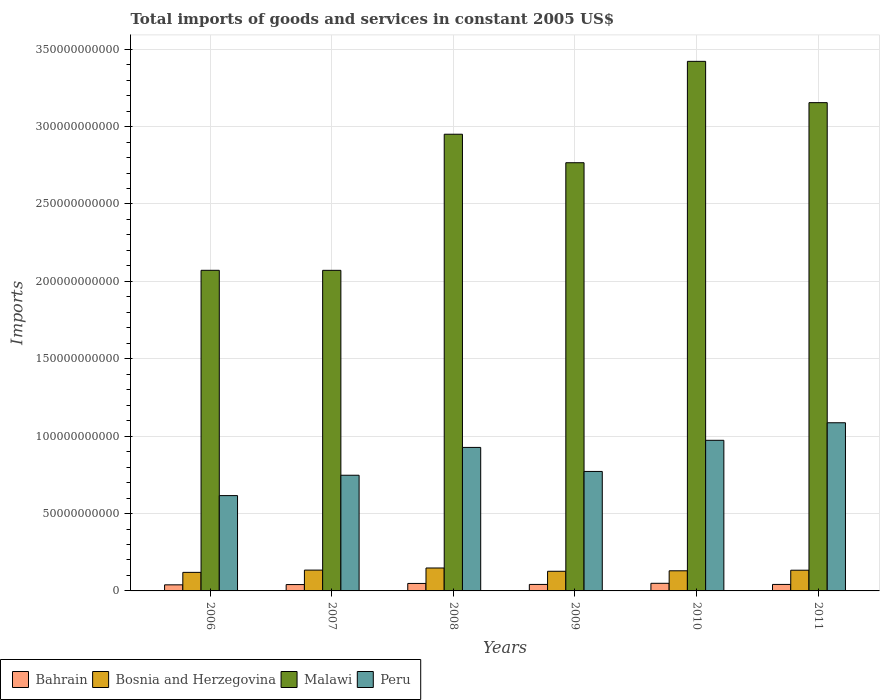How many different coloured bars are there?
Your answer should be very brief. 4. How many groups of bars are there?
Provide a succinct answer. 6. How many bars are there on the 2nd tick from the left?
Keep it short and to the point. 4. How many bars are there on the 2nd tick from the right?
Give a very brief answer. 4. What is the label of the 6th group of bars from the left?
Your answer should be very brief. 2011. In how many cases, is the number of bars for a given year not equal to the number of legend labels?
Offer a terse response. 0. What is the total imports of goods and services in Peru in 2011?
Ensure brevity in your answer.  1.09e+11. Across all years, what is the maximum total imports of goods and services in Peru?
Provide a succinct answer. 1.09e+11. Across all years, what is the minimum total imports of goods and services in Peru?
Make the answer very short. 6.16e+1. In which year was the total imports of goods and services in Bahrain maximum?
Offer a very short reply. 2010. What is the total total imports of goods and services in Malawi in the graph?
Give a very brief answer. 1.64e+12. What is the difference between the total imports of goods and services in Malawi in 2010 and that in 2011?
Provide a succinct answer. 2.67e+1. What is the difference between the total imports of goods and services in Peru in 2011 and the total imports of goods and services in Bahrain in 2006?
Your response must be concise. 1.05e+11. What is the average total imports of goods and services in Bahrain per year?
Ensure brevity in your answer.  4.36e+09. In the year 2007, what is the difference between the total imports of goods and services in Bosnia and Herzegovina and total imports of goods and services in Peru?
Provide a short and direct response. -6.13e+1. In how many years, is the total imports of goods and services in Bosnia and Herzegovina greater than 130000000000 US$?
Your answer should be very brief. 0. What is the ratio of the total imports of goods and services in Peru in 2007 to that in 2008?
Your response must be concise. 0.81. Is the total imports of goods and services in Peru in 2010 less than that in 2011?
Ensure brevity in your answer.  Yes. Is the difference between the total imports of goods and services in Bosnia and Herzegovina in 2010 and 2011 greater than the difference between the total imports of goods and services in Peru in 2010 and 2011?
Your response must be concise. Yes. What is the difference between the highest and the second highest total imports of goods and services in Peru?
Make the answer very short. 1.13e+1. What is the difference between the highest and the lowest total imports of goods and services in Bosnia and Herzegovina?
Keep it short and to the point. 2.83e+09. Is the sum of the total imports of goods and services in Bahrain in 2006 and 2008 greater than the maximum total imports of goods and services in Bosnia and Herzegovina across all years?
Your answer should be compact. No. Is it the case that in every year, the sum of the total imports of goods and services in Bahrain and total imports of goods and services in Bosnia and Herzegovina is greater than the sum of total imports of goods and services in Malawi and total imports of goods and services in Peru?
Keep it short and to the point. No. What does the 3rd bar from the right in 2006 represents?
Your answer should be very brief. Bosnia and Herzegovina. What is the difference between two consecutive major ticks on the Y-axis?
Offer a terse response. 5.00e+1. Does the graph contain grids?
Keep it short and to the point. Yes. Where does the legend appear in the graph?
Ensure brevity in your answer.  Bottom left. What is the title of the graph?
Ensure brevity in your answer.  Total imports of goods and services in constant 2005 US$. What is the label or title of the Y-axis?
Offer a terse response. Imports. What is the Imports of Bahrain in 2006?
Keep it short and to the point. 3.93e+09. What is the Imports of Bosnia and Herzegovina in 2006?
Offer a very short reply. 1.20e+1. What is the Imports in Malawi in 2006?
Give a very brief answer. 2.07e+11. What is the Imports of Peru in 2006?
Your response must be concise. 6.16e+1. What is the Imports of Bahrain in 2007?
Provide a succinct answer. 4.10e+09. What is the Imports in Bosnia and Herzegovina in 2007?
Your answer should be very brief. 1.35e+1. What is the Imports of Malawi in 2007?
Your answer should be very brief. 2.07e+11. What is the Imports of Peru in 2007?
Your answer should be compact. 7.47e+1. What is the Imports of Bahrain in 2008?
Provide a succinct answer. 4.83e+09. What is the Imports of Bosnia and Herzegovina in 2008?
Your answer should be compact. 1.48e+1. What is the Imports of Malawi in 2008?
Give a very brief answer. 2.95e+11. What is the Imports of Peru in 2008?
Make the answer very short. 9.27e+1. What is the Imports of Bahrain in 2009?
Keep it short and to the point. 4.20e+09. What is the Imports in Bosnia and Herzegovina in 2009?
Give a very brief answer. 1.27e+1. What is the Imports in Malawi in 2009?
Provide a short and direct response. 2.77e+11. What is the Imports of Peru in 2009?
Offer a terse response. 7.72e+1. What is the Imports of Bahrain in 2010?
Provide a short and direct response. 4.92e+09. What is the Imports in Bosnia and Herzegovina in 2010?
Keep it short and to the point. 1.30e+1. What is the Imports of Malawi in 2010?
Make the answer very short. 3.42e+11. What is the Imports in Peru in 2010?
Ensure brevity in your answer.  9.73e+1. What is the Imports in Bahrain in 2011?
Provide a short and direct response. 4.20e+09. What is the Imports in Bosnia and Herzegovina in 2011?
Your answer should be very brief. 1.34e+1. What is the Imports in Malawi in 2011?
Make the answer very short. 3.15e+11. What is the Imports in Peru in 2011?
Make the answer very short. 1.09e+11. Across all years, what is the maximum Imports of Bahrain?
Offer a very short reply. 4.92e+09. Across all years, what is the maximum Imports of Bosnia and Herzegovina?
Give a very brief answer. 1.48e+1. Across all years, what is the maximum Imports of Malawi?
Your answer should be very brief. 3.42e+11. Across all years, what is the maximum Imports of Peru?
Provide a succinct answer. 1.09e+11. Across all years, what is the minimum Imports of Bahrain?
Provide a succinct answer. 3.93e+09. Across all years, what is the minimum Imports in Bosnia and Herzegovina?
Provide a succinct answer. 1.20e+1. Across all years, what is the minimum Imports in Malawi?
Offer a terse response. 2.07e+11. Across all years, what is the minimum Imports of Peru?
Offer a terse response. 6.16e+1. What is the total Imports in Bahrain in the graph?
Make the answer very short. 2.62e+1. What is the total Imports in Bosnia and Herzegovina in the graph?
Provide a short and direct response. 7.93e+1. What is the total Imports in Malawi in the graph?
Your answer should be very brief. 1.64e+12. What is the total Imports in Peru in the graph?
Provide a succinct answer. 5.12e+11. What is the difference between the Imports in Bahrain in 2006 and that in 2007?
Offer a very short reply. -1.75e+08. What is the difference between the Imports in Bosnia and Herzegovina in 2006 and that in 2007?
Your response must be concise. -1.47e+09. What is the difference between the Imports in Malawi in 2006 and that in 2007?
Your answer should be very brief. 2.19e+07. What is the difference between the Imports in Peru in 2006 and that in 2007?
Ensure brevity in your answer.  -1.31e+1. What is the difference between the Imports in Bahrain in 2006 and that in 2008?
Your answer should be very brief. -9.05e+08. What is the difference between the Imports of Bosnia and Herzegovina in 2006 and that in 2008?
Provide a succinct answer. -2.83e+09. What is the difference between the Imports of Malawi in 2006 and that in 2008?
Offer a very short reply. -8.79e+1. What is the difference between the Imports in Peru in 2006 and that in 2008?
Provide a short and direct response. -3.11e+1. What is the difference between the Imports of Bahrain in 2006 and that in 2009?
Make the answer very short. -2.68e+08. What is the difference between the Imports in Bosnia and Herzegovina in 2006 and that in 2009?
Keep it short and to the point. -7.04e+08. What is the difference between the Imports in Malawi in 2006 and that in 2009?
Offer a very short reply. -6.95e+1. What is the difference between the Imports of Peru in 2006 and that in 2009?
Give a very brief answer. -1.56e+1. What is the difference between the Imports in Bahrain in 2006 and that in 2010?
Offer a terse response. -9.95e+08. What is the difference between the Imports of Bosnia and Herzegovina in 2006 and that in 2010?
Provide a succinct answer. -1.02e+09. What is the difference between the Imports in Malawi in 2006 and that in 2010?
Your answer should be very brief. -1.35e+11. What is the difference between the Imports in Peru in 2006 and that in 2010?
Provide a short and direct response. -3.57e+1. What is the difference between the Imports in Bahrain in 2006 and that in 2011?
Offer a terse response. -2.68e+08. What is the difference between the Imports in Bosnia and Herzegovina in 2006 and that in 2011?
Ensure brevity in your answer.  -1.40e+09. What is the difference between the Imports of Malawi in 2006 and that in 2011?
Offer a very short reply. -1.08e+11. What is the difference between the Imports in Peru in 2006 and that in 2011?
Keep it short and to the point. -4.71e+1. What is the difference between the Imports of Bahrain in 2007 and that in 2008?
Make the answer very short. -7.30e+08. What is the difference between the Imports of Bosnia and Herzegovina in 2007 and that in 2008?
Offer a very short reply. -1.36e+09. What is the difference between the Imports of Malawi in 2007 and that in 2008?
Offer a very short reply. -8.79e+1. What is the difference between the Imports of Peru in 2007 and that in 2008?
Offer a very short reply. -1.80e+1. What is the difference between the Imports of Bahrain in 2007 and that in 2009?
Your answer should be very brief. -9.39e+07. What is the difference between the Imports of Bosnia and Herzegovina in 2007 and that in 2009?
Ensure brevity in your answer.  7.62e+08. What is the difference between the Imports in Malawi in 2007 and that in 2009?
Give a very brief answer. -6.95e+1. What is the difference between the Imports in Peru in 2007 and that in 2009?
Your answer should be compact. -2.46e+09. What is the difference between the Imports of Bahrain in 2007 and that in 2010?
Your response must be concise. -8.20e+08. What is the difference between the Imports in Bosnia and Herzegovina in 2007 and that in 2010?
Ensure brevity in your answer.  4.48e+08. What is the difference between the Imports of Malawi in 2007 and that in 2010?
Keep it short and to the point. -1.35e+11. What is the difference between the Imports in Peru in 2007 and that in 2010?
Keep it short and to the point. -2.26e+1. What is the difference between the Imports of Bahrain in 2007 and that in 2011?
Offer a very short reply. -9.29e+07. What is the difference between the Imports of Bosnia and Herzegovina in 2007 and that in 2011?
Keep it short and to the point. 6.82e+07. What is the difference between the Imports of Malawi in 2007 and that in 2011?
Give a very brief answer. -1.08e+11. What is the difference between the Imports in Peru in 2007 and that in 2011?
Your answer should be very brief. -3.39e+1. What is the difference between the Imports of Bahrain in 2008 and that in 2009?
Your answer should be compact. 6.36e+08. What is the difference between the Imports of Bosnia and Herzegovina in 2008 and that in 2009?
Ensure brevity in your answer.  2.13e+09. What is the difference between the Imports of Malawi in 2008 and that in 2009?
Give a very brief answer. 1.84e+1. What is the difference between the Imports of Peru in 2008 and that in 2009?
Your answer should be very brief. 1.55e+1. What is the difference between the Imports of Bahrain in 2008 and that in 2010?
Your answer should be very brief. -9.00e+07. What is the difference between the Imports of Bosnia and Herzegovina in 2008 and that in 2010?
Make the answer very short. 1.81e+09. What is the difference between the Imports in Malawi in 2008 and that in 2010?
Provide a short and direct response. -4.71e+1. What is the difference between the Imports of Peru in 2008 and that in 2010?
Offer a terse response. -4.60e+09. What is the difference between the Imports in Bahrain in 2008 and that in 2011?
Provide a succinct answer. 6.38e+08. What is the difference between the Imports of Bosnia and Herzegovina in 2008 and that in 2011?
Make the answer very short. 1.43e+09. What is the difference between the Imports in Malawi in 2008 and that in 2011?
Provide a short and direct response. -2.04e+1. What is the difference between the Imports of Peru in 2008 and that in 2011?
Your answer should be very brief. -1.59e+1. What is the difference between the Imports in Bahrain in 2009 and that in 2010?
Your answer should be compact. -7.26e+08. What is the difference between the Imports in Bosnia and Herzegovina in 2009 and that in 2010?
Ensure brevity in your answer.  -3.15e+08. What is the difference between the Imports in Malawi in 2009 and that in 2010?
Offer a very short reply. -6.55e+1. What is the difference between the Imports of Peru in 2009 and that in 2010?
Give a very brief answer. -2.01e+1. What is the difference between the Imports of Bahrain in 2009 and that in 2011?
Offer a very short reply. 1.00e+06. What is the difference between the Imports in Bosnia and Herzegovina in 2009 and that in 2011?
Your answer should be compact. -6.94e+08. What is the difference between the Imports in Malawi in 2009 and that in 2011?
Offer a very short reply. -3.88e+1. What is the difference between the Imports in Peru in 2009 and that in 2011?
Your response must be concise. -3.15e+1. What is the difference between the Imports in Bahrain in 2010 and that in 2011?
Provide a succinct answer. 7.28e+08. What is the difference between the Imports in Bosnia and Herzegovina in 2010 and that in 2011?
Offer a terse response. -3.79e+08. What is the difference between the Imports of Malawi in 2010 and that in 2011?
Make the answer very short. 2.67e+1. What is the difference between the Imports in Peru in 2010 and that in 2011?
Keep it short and to the point. -1.13e+1. What is the difference between the Imports in Bahrain in 2006 and the Imports in Bosnia and Herzegovina in 2007?
Keep it short and to the point. -9.52e+09. What is the difference between the Imports in Bahrain in 2006 and the Imports in Malawi in 2007?
Ensure brevity in your answer.  -2.03e+11. What is the difference between the Imports in Bahrain in 2006 and the Imports in Peru in 2007?
Your response must be concise. -7.08e+1. What is the difference between the Imports in Bosnia and Herzegovina in 2006 and the Imports in Malawi in 2007?
Provide a short and direct response. -1.95e+11. What is the difference between the Imports of Bosnia and Herzegovina in 2006 and the Imports of Peru in 2007?
Provide a short and direct response. -6.27e+1. What is the difference between the Imports of Malawi in 2006 and the Imports of Peru in 2007?
Your answer should be compact. 1.32e+11. What is the difference between the Imports of Bahrain in 2006 and the Imports of Bosnia and Herzegovina in 2008?
Give a very brief answer. -1.09e+1. What is the difference between the Imports of Bahrain in 2006 and the Imports of Malawi in 2008?
Your response must be concise. -2.91e+11. What is the difference between the Imports of Bahrain in 2006 and the Imports of Peru in 2008?
Provide a succinct answer. -8.88e+1. What is the difference between the Imports in Bosnia and Herzegovina in 2006 and the Imports in Malawi in 2008?
Make the answer very short. -2.83e+11. What is the difference between the Imports of Bosnia and Herzegovina in 2006 and the Imports of Peru in 2008?
Give a very brief answer. -8.07e+1. What is the difference between the Imports of Malawi in 2006 and the Imports of Peru in 2008?
Keep it short and to the point. 1.14e+11. What is the difference between the Imports in Bahrain in 2006 and the Imports in Bosnia and Herzegovina in 2009?
Make the answer very short. -8.76e+09. What is the difference between the Imports in Bahrain in 2006 and the Imports in Malawi in 2009?
Offer a very short reply. -2.73e+11. What is the difference between the Imports of Bahrain in 2006 and the Imports of Peru in 2009?
Your answer should be very brief. -7.33e+1. What is the difference between the Imports in Bosnia and Herzegovina in 2006 and the Imports in Malawi in 2009?
Provide a succinct answer. -2.65e+11. What is the difference between the Imports in Bosnia and Herzegovina in 2006 and the Imports in Peru in 2009?
Your answer should be compact. -6.52e+1. What is the difference between the Imports of Malawi in 2006 and the Imports of Peru in 2009?
Your response must be concise. 1.30e+11. What is the difference between the Imports of Bahrain in 2006 and the Imports of Bosnia and Herzegovina in 2010?
Keep it short and to the point. -9.08e+09. What is the difference between the Imports in Bahrain in 2006 and the Imports in Malawi in 2010?
Give a very brief answer. -3.38e+11. What is the difference between the Imports in Bahrain in 2006 and the Imports in Peru in 2010?
Provide a succinct answer. -9.34e+1. What is the difference between the Imports of Bosnia and Herzegovina in 2006 and the Imports of Malawi in 2010?
Provide a short and direct response. -3.30e+11. What is the difference between the Imports of Bosnia and Herzegovina in 2006 and the Imports of Peru in 2010?
Give a very brief answer. -8.53e+1. What is the difference between the Imports in Malawi in 2006 and the Imports in Peru in 2010?
Offer a very short reply. 1.10e+11. What is the difference between the Imports of Bahrain in 2006 and the Imports of Bosnia and Herzegovina in 2011?
Your answer should be compact. -9.46e+09. What is the difference between the Imports in Bahrain in 2006 and the Imports in Malawi in 2011?
Offer a terse response. -3.12e+11. What is the difference between the Imports in Bahrain in 2006 and the Imports in Peru in 2011?
Your answer should be compact. -1.05e+11. What is the difference between the Imports in Bosnia and Herzegovina in 2006 and the Imports in Malawi in 2011?
Your answer should be very brief. -3.03e+11. What is the difference between the Imports in Bosnia and Herzegovina in 2006 and the Imports in Peru in 2011?
Your answer should be very brief. -9.67e+1. What is the difference between the Imports of Malawi in 2006 and the Imports of Peru in 2011?
Make the answer very short. 9.85e+1. What is the difference between the Imports in Bahrain in 2007 and the Imports in Bosnia and Herzegovina in 2008?
Make the answer very short. -1.07e+1. What is the difference between the Imports in Bahrain in 2007 and the Imports in Malawi in 2008?
Your answer should be compact. -2.91e+11. What is the difference between the Imports of Bahrain in 2007 and the Imports of Peru in 2008?
Provide a short and direct response. -8.86e+1. What is the difference between the Imports of Bosnia and Herzegovina in 2007 and the Imports of Malawi in 2008?
Your answer should be very brief. -2.82e+11. What is the difference between the Imports of Bosnia and Herzegovina in 2007 and the Imports of Peru in 2008?
Make the answer very short. -7.93e+1. What is the difference between the Imports of Malawi in 2007 and the Imports of Peru in 2008?
Your response must be concise. 1.14e+11. What is the difference between the Imports of Bahrain in 2007 and the Imports of Bosnia and Herzegovina in 2009?
Offer a very short reply. -8.59e+09. What is the difference between the Imports in Bahrain in 2007 and the Imports in Malawi in 2009?
Offer a terse response. -2.73e+11. What is the difference between the Imports of Bahrain in 2007 and the Imports of Peru in 2009?
Give a very brief answer. -7.31e+1. What is the difference between the Imports in Bosnia and Herzegovina in 2007 and the Imports in Malawi in 2009?
Provide a succinct answer. -2.63e+11. What is the difference between the Imports of Bosnia and Herzegovina in 2007 and the Imports of Peru in 2009?
Your answer should be very brief. -6.37e+1. What is the difference between the Imports in Malawi in 2007 and the Imports in Peru in 2009?
Keep it short and to the point. 1.30e+11. What is the difference between the Imports of Bahrain in 2007 and the Imports of Bosnia and Herzegovina in 2010?
Ensure brevity in your answer.  -8.90e+09. What is the difference between the Imports in Bahrain in 2007 and the Imports in Malawi in 2010?
Offer a very short reply. -3.38e+11. What is the difference between the Imports of Bahrain in 2007 and the Imports of Peru in 2010?
Make the answer very short. -9.32e+1. What is the difference between the Imports in Bosnia and Herzegovina in 2007 and the Imports in Malawi in 2010?
Give a very brief answer. -3.29e+11. What is the difference between the Imports of Bosnia and Herzegovina in 2007 and the Imports of Peru in 2010?
Your answer should be compact. -8.39e+1. What is the difference between the Imports of Malawi in 2007 and the Imports of Peru in 2010?
Give a very brief answer. 1.10e+11. What is the difference between the Imports of Bahrain in 2007 and the Imports of Bosnia and Herzegovina in 2011?
Your response must be concise. -9.28e+09. What is the difference between the Imports of Bahrain in 2007 and the Imports of Malawi in 2011?
Your answer should be very brief. -3.11e+11. What is the difference between the Imports in Bahrain in 2007 and the Imports in Peru in 2011?
Your answer should be compact. -1.05e+11. What is the difference between the Imports in Bosnia and Herzegovina in 2007 and the Imports in Malawi in 2011?
Your answer should be very brief. -3.02e+11. What is the difference between the Imports in Bosnia and Herzegovina in 2007 and the Imports in Peru in 2011?
Your response must be concise. -9.52e+1. What is the difference between the Imports in Malawi in 2007 and the Imports in Peru in 2011?
Provide a short and direct response. 9.85e+1. What is the difference between the Imports in Bahrain in 2008 and the Imports in Bosnia and Herzegovina in 2009?
Provide a short and direct response. -7.86e+09. What is the difference between the Imports in Bahrain in 2008 and the Imports in Malawi in 2009?
Make the answer very short. -2.72e+11. What is the difference between the Imports in Bahrain in 2008 and the Imports in Peru in 2009?
Offer a very short reply. -7.24e+1. What is the difference between the Imports of Bosnia and Herzegovina in 2008 and the Imports of Malawi in 2009?
Give a very brief answer. -2.62e+11. What is the difference between the Imports of Bosnia and Herzegovina in 2008 and the Imports of Peru in 2009?
Ensure brevity in your answer.  -6.24e+1. What is the difference between the Imports in Malawi in 2008 and the Imports in Peru in 2009?
Make the answer very short. 2.18e+11. What is the difference between the Imports in Bahrain in 2008 and the Imports in Bosnia and Herzegovina in 2010?
Your answer should be very brief. -8.17e+09. What is the difference between the Imports in Bahrain in 2008 and the Imports in Malawi in 2010?
Offer a terse response. -3.37e+11. What is the difference between the Imports of Bahrain in 2008 and the Imports of Peru in 2010?
Keep it short and to the point. -9.25e+1. What is the difference between the Imports in Bosnia and Herzegovina in 2008 and the Imports in Malawi in 2010?
Offer a very short reply. -3.27e+11. What is the difference between the Imports of Bosnia and Herzegovina in 2008 and the Imports of Peru in 2010?
Your answer should be very brief. -8.25e+1. What is the difference between the Imports of Malawi in 2008 and the Imports of Peru in 2010?
Offer a terse response. 1.98e+11. What is the difference between the Imports of Bahrain in 2008 and the Imports of Bosnia and Herzegovina in 2011?
Offer a very short reply. -8.55e+09. What is the difference between the Imports of Bahrain in 2008 and the Imports of Malawi in 2011?
Your answer should be compact. -3.11e+11. What is the difference between the Imports of Bahrain in 2008 and the Imports of Peru in 2011?
Make the answer very short. -1.04e+11. What is the difference between the Imports in Bosnia and Herzegovina in 2008 and the Imports in Malawi in 2011?
Your response must be concise. -3.01e+11. What is the difference between the Imports in Bosnia and Herzegovina in 2008 and the Imports in Peru in 2011?
Keep it short and to the point. -9.38e+1. What is the difference between the Imports of Malawi in 2008 and the Imports of Peru in 2011?
Provide a short and direct response. 1.86e+11. What is the difference between the Imports in Bahrain in 2009 and the Imports in Bosnia and Herzegovina in 2010?
Make the answer very short. -8.81e+09. What is the difference between the Imports of Bahrain in 2009 and the Imports of Malawi in 2010?
Your answer should be compact. -3.38e+11. What is the difference between the Imports of Bahrain in 2009 and the Imports of Peru in 2010?
Provide a short and direct response. -9.31e+1. What is the difference between the Imports of Bosnia and Herzegovina in 2009 and the Imports of Malawi in 2010?
Provide a short and direct response. -3.29e+11. What is the difference between the Imports in Bosnia and Herzegovina in 2009 and the Imports in Peru in 2010?
Provide a short and direct response. -8.46e+1. What is the difference between the Imports in Malawi in 2009 and the Imports in Peru in 2010?
Your answer should be very brief. 1.79e+11. What is the difference between the Imports of Bahrain in 2009 and the Imports of Bosnia and Herzegovina in 2011?
Your response must be concise. -9.19e+09. What is the difference between the Imports in Bahrain in 2009 and the Imports in Malawi in 2011?
Your response must be concise. -3.11e+11. What is the difference between the Imports in Bahrain in 2009 and the Imports in Peru in 2011?
Provide a short and direct response. -1.04e+11. What is the difference between the Imports of Bosnia and Herzegovina in 2009 and the Imports of Malawi in 2011?
Your answer should be compact. -3.03e+11. What is the difference between the Imports of Bosnia and Herzegovina in 2009 and the Imports of Peru in 2011?
Make the answer very short. -9.60e+1. What is the difference between the Imports of Malawi in 2009 and the Imports of Peru in 2011?
Give a very brief answer. 1.68e+11. What is the difference between the Imports in Bahrain in 2010 and the Imports in Bosnia and Herzegovina in 2011?
Provide a succinct answer. -8.46e+09. What is the difference between the Imports in Bahrain in 2010 and the Imports in Malawi in 2011?
Offer a terse response. -3.11e+11. What is the difference between the Imports in Bahrain in 2010 and the Imports in Peru in 2011?
Offer a terse response. -1.04e+11. What is the difference between the Imports in Bosnia and Herzegovina in 2010 and the Imports in Malawi in 2011?
Ensure brevity in your answer.  -3.02e+11. What is the difference between the Imports of Bosnia and Herzegovina in 2010 and the Imports of Peru in 2011?
Offer a terse response. -9.56e+1. What is the difference between the Imports in Malawi in 2010 and the Imports in Peru in 2011?
Make the answer very short. 2.34e+11. What is the average Imports of Bahrain per year?
Ensure brevity in your answer.  4.36e+09. What is the average Imports in Bosnia and Herzegovina per year?
Give a very brief answer. 1.32e+1. What is the average Imports of Malawi per year?
Your answer should be compact. 2.74e+11. What is the average Imports in Peru per year?
Your answer should be very brief. 8.54e+1. In the year 2006, what is the difference between the Imports in Bahrain and Imports in Bosnia and Herzegovina?
Offer a terse response. -8.06e+09. In the year 2006, what is the difference between the Imports of Bahrain and Imports of Malawi?
Offer a terse response. -2.03e+11. In the year 2006, what is the difference between the Imports in Bahrain and Imports in Peru?
Your response must be concise. -5.77e+1. In the year 2006, what is the difference between the Imports of Bosnia and Herzegovina and Imports of Malawi?
Your response must be concise. -1.95e+11. In the year 2006, what is the difference between the Imports of Bosnia and Herzegovina and Imports of Peru?
Your response must be concise. -4.96e+1. In the year 2006, what is the difference between the Imports in Malawi and Imports in Peru?
Provide a succinct answer. 1.46e+11. In the year 2007, what is the difference between the Imports of Bahrain and Imports of Bosnia and Herzegovina?
Your answer should be compact. -9.35e+09. In the year 2007, what is the difference between the Imports of Bahrain and Imports of Malawi?
Offer a very short reply. -2.03e+11. In the year 2007, what is the difference between the Imports in Bahrain and Imports in Peru?
Ensure brevity in your answer.  -7.06e+1. In the year 2007, what is the difference between the Imports in Bosnia and Herzegovina and Imports in Malawi?
Provide a short and direct response. -1.94e+11. In the year 2007, what is the difference between the Imports of Bosnia and Herzegovina and Imports of Peru?
Your response must be concise. -6.13e+1. In the year 2007, what is the difference between the Imports of Malawi and Imports of Peru?
Your answer should be compact. 1.32e+11. In the year 2008, what is the difference between the Imports of Bahrain and Imports of Bosnia and Herzegovina?
Your answer should be compact. -9.98e+09. In the year 2008, what is the difference between the Imports of Bahrain and Imports of Malawi?
Offer a terse response. -2.90e+11. In the year 2008, what is the difference between the Imports of Bahrain and Imports of Peru?
Keep it short and to the point. -8.79e+1. In the year 2008, what is the difference between the Imports in Bosnia and Herzegovina and Imports in Malawi?
Ensure brevity in your answer.  -2.80e+11. In the year 2008, what is the difference between the Imports in Bosnia and Herzegovina and Imports in Peru?
Your response must be concise. -7.79e+1. In the year 2008, what is the difference between the Imports in Malawi and Imports in Peru?
Your response must be concise. 2.02e+11. In the year 2009, what is the difference between the Imports in Bahrain and Imports in Bosnia and Herzegovina?
Make the answer very short. -8.49e+09. In the year 2009, what is the difference between the Imports in Bahrain and Imports in Malawi?
Your answer should be compact. -2.72e+11. In the year 2009, what is the difference between the Imports of Bahrain and Imports of Peru?
Provide a succinct answer. -7.30e+1. In the year 2009, what is the difference between the Imports of Bosnia and Herzegovina and Imports of Malawi?
Your response must be concise. -2.64e+11. In the year 2009, what is the difference between the Imports of Bosnia and Herzegovina and Imports of Peru?
Make the answer very short. -6.45e+1. In the year 2009, what is the difference between the Imports of Malawi and Imports of Peru?
Your answer should be very brief. 1.99e+11. In the year 2010, what is the difference between the Imports in Bahrain and Imports in Bosnia and Herzegovina?
Provide a short and direct response. -8.08e+09. In the year 2010, what is the difference between the Imports in Bahrain and Imports in Malawi?
Keep it short and to the point. -3.37e+11. In the year 2010, what is the difference between the Imports of Bahrain and Imports of Peru?
Give a very brief answer. -9.24e+1. In the year 2010, what is the difference between the Imports of Bosnia and Herzegovina and Imports of Malawi?
Offer a very short reply. -3.29e+11. In the year 2010, what is the difference between the Imports of Bosnia and Herzegovina and Imports of Peru?
Your response must be concise. -8.43e+1. In the year 2010, what is the difference between the Imports in Malawi and Imports in Peru?
Your answer should be very brief. 2.45e+11. In the year 2011, what is the difference between the Imports of Bahrain and Imports of Bosnia and Herzegovina?
Make the answer very short. -9.19e+09. In the year 2011, what is the difference between the Imports of Bahrain and Imports of Malawi?
Your answer should be very brief. -3.11e+11. In the year 2011, what is the difference between the Imports in Bahrain and Imports in Peru?
Make the answer very short. -1.04e+11. In the year 2011, what is the difference between the Imports of Bosnia and Herzegovina and Imports of Malawi?
Your answer should be compact. -3.02e+11. In the year 2011, what is the difference between the Imports of Bosnia and Herzegovina and Imports of Peru?
Provide a succinct answer. -9.53e+1. In the year 2011, what is the difference between the Imports of Malawi and Imports of Peru?
Your response must be concise. 2.07e+11. What is the ratio of the Imports of Bahrain in 2006 to that in 2007?
Offer a very short reply. 0.96. What is the ratio of the Imports of Bosnia and Herzegovina in 2006 to that in 2007?
Offer a terse response. 0.89. What is the ratio of the Imports of Malawi in 2006 to that in 2007?
Your answer should be very brief. 1. What is the ratio of the Imports of Peru in 2006 to that in 2007?
Your response must be concise. 0.82. What is the ratio of the Imports of Bahrain in 2006 to that in 2008?
Offer a terse response. 0.81. What is the ratio of the Imports in Bosnia and Herzegovina in 2006 to that in 2008?
Offer a very short reply. 0.81. What is the ratio of the Imports of Malawi in 2006 to that in 2008?
Give a very brief answer. 0.7. What is the ratio of the Imports in Peru in 2006 to that in 2008?
Offer a terse response. 0.66. What is the ratio of the Imports of Bahrain in 2006 to that in 2009?
Your answer should be compact. 0.94. What is the ratio of the Imports in Bosnia and Herzegovina in 2006 to that in 2009?
Provide a succinct answer. 0.94. What is the ratio of the Imports in Malawi in 2006 to that in 2009?
Provide a short and direct response. 0.75. What is the ratio of the Imports in Peru in 2006 to that in 2009?
Offer a very short reply. 0.8. What is the ratio of the Imports in Bahrain in 2006 to that in 2010?
Provide a short and direct response. 0.8. What is the ratio of the Imports of Bosnia and Herzegovina in 2006 to that in 2010?
Provide a succinct answer. 0.92. What is the ratio of the Imports of Malawi in 2006 to that in 2010?
Your answer should be compact. 0.61. What is the ratio of the Imports of Peru in 2006 to that in 2010?
Your answer should be very brief. 0.63. What is the ratio of the Imports of Bahrain in 2006 to that in 2011?
Offer a very short reply. 0.94. What is the ratio of the Imports of Bosnia and Herzegovina in 2006 to that in 2011?
Your response must be concise. 0.9. What is the ratio of the Imports in Malawi in 2006 to that in 2011?
Your answer should be very brief. 0.66. What is the ratio of the Imports of Peru in 2006 to that in 2011?
Give a very brief answer. 0.57. What is the ratio of the Imports in Bahrain in 2007 to that in 2008?
Your answer should be very brief. 0.85. What is the ratio of the Imports in Bosnia and Herzegovina in 2007 to that in 2008?
Offer a terse response. 0.91. What is the ratio of the Imports in Malawi in 2007 to that in 2008?
Offer a very short reply. 0.7. What is the ratio of the Imports of Peru in 2007 to that in 2008?
Your answer should be compact. 0.81. What is the ratio of the Imports of Bahrain in 2007 to that in 2009?
Offer a very short reply. 0.98. What is the ratio of the Imports in Bosnia and Herzegovina in 2007 to that in 2009?
Provide a succinct answer. 1.06. What is the ratio of the Imports in Malawi in 2007 to that in 2009?
Provide a short and direct response. 0.75. What is the ratio of the Imports of Peru in 2007 to that in 2009?
Offer a very short reply. 0.97. What is the ratio of the Imports in Bahrain in 2007 to that in 2010?
Your answer should be very brief. 0.83. What is the ratio of the Imports of Bosnia and Herzegovina in 2007 to that in 2010?
Your answer should be compact. 1.03. What is the ratio of the Imports in Malawi in 2007 to that in 2010?
Keep it short and to the point. 0.61. What is the ratio of the Imports of Peru in 2007 to that in 2010?
Offer a very short reply. 0.77. What is the ratio of the Imports in Bahrain in 2007 to that in 2011?
Your response must be concise. 0.98. What is the ratio of the Imports of Malawi in 2007 to that in 2011?
Offer a terse response. 0.66. What is the ratio of the Imports of Peru in 2007 to that in 2011?
Keep it short and to the point. 0.69. What is the ratio of the Imports in Bahrain in 2008 to that in 2009?
Provide a short and direct response. 1.15. What is the ratio of the Imports in Bosnia and Herzegovina in 2008 to that in 2009?
Provide a succinct answer. 1.17. What is the ratio of the Imports in Malawi in 2008 to that in 2009?
Offer a very short reply. 1.07. What is the ratio of the Imports of Peru in 2008 to that in 2009?
Keep it short and to the point. 1.2. What is the ratio of the Imports of Bahrain in 2008 to that in 2010?
Provide a short and direct response. 0.98. What is the ratio of the Imports in Bosnia and Herzegovina in 2008 to that in 2010?
Offer a very short reply. 1.14. What is the ratio of the Imports in Malawi in 2008 to that in 2010?
Your answer should be very brief. 0.86. What is the ratio of the Imports of Peru in 2008 to that in 2010?
Provide a short and direct response. 0.95. What is the ratio of the Imports in Bahrain in 2008 to that in 2011?
Make the answer very short. 1.15. What is the ratio of the Imports of Bosnia and Herzegovina in 2008 to that in 2011?
Provide a short and direct response. 1.11. What is the ratio of the Imports in Malawi in 2008 to that in 2011?
Offer a terse response. 0.94. What is the ratio of the Imports in Peru in 2008 to that in 2011?
Offer a terse response. 0.85. What is the ratio of the Imports in Bahrain in 2009 to that in 2010?
Keep it short and to the point. 0.85. What is the ratio of the Imports in Bosnia and Herzegovina in 2009 to that in 2010?
Offer a terse response. 0.98. What is the ratio of the Imports in Malawi in 2009 to that in 2010?
Offer a terse response. 0.81. What is the ratio of the Imports of Peru in 2009 to that in 2010?
Offer a very short reply. 0.79. What is the ratio of the Imports of Bosnia and Herzegovina in 2009 to that in 2011?
Your answer should be compact. 0.95. What is the ratio of the Imports of Malawi in 2009 to that in 2011?
Your answer should be compact. 0.88. What is the ratio of the Imports of Peru in 2009 to that in 2011?
Your answer should be compact. 0.71. What is the ratio of the Imports of Bahrain in 2010 to that in 2011?
Keep it short and to the point. 1.17. What is the ratio of the Imports of Bosnia and Herzegovina in 2010 to that in 2011?
Make the answer very short. 0.97. What is the ratio of the Imports of Malawi in 2010 to that in 2011?
Your answer should be very brief. 1.08. What is the ratio of the Imports of Peru in 2010 to that in 2011?
Offer a terse response. 0.9. What is the difference between the highest and the second highest Imports of Bahrain?
Provide a succinct answer. 9.00e+07. What is the difference between the highest and the second highest Imports in Bosnia and Herzegovina?
Provide a short and direct response. 1.36e+09. What is the difference between the highest and the second highest Imports of Malawi?
Ensure brevity in your answer.  2.67e+1. What is the difference between the highest and the second highest Imports of Peru?
Ensure brevity in your answer.  1.13e+1. What is the difference between the highest and the lowest Imports of Bahrain?
Give a very brief answer. 9.95e+08. What is the difference between the highest and the lowest Imports of Bosnia and Herzegovina?
Offer a terse response. 2.83e+09. What is the difference between the highest and the lowest Imports in Malawi?
Your answer should be very brief. 1.35e+11. What is the difference between the highest and the lowest Imports in Peru?
Your answer should be very brief. 4.71e+1. 